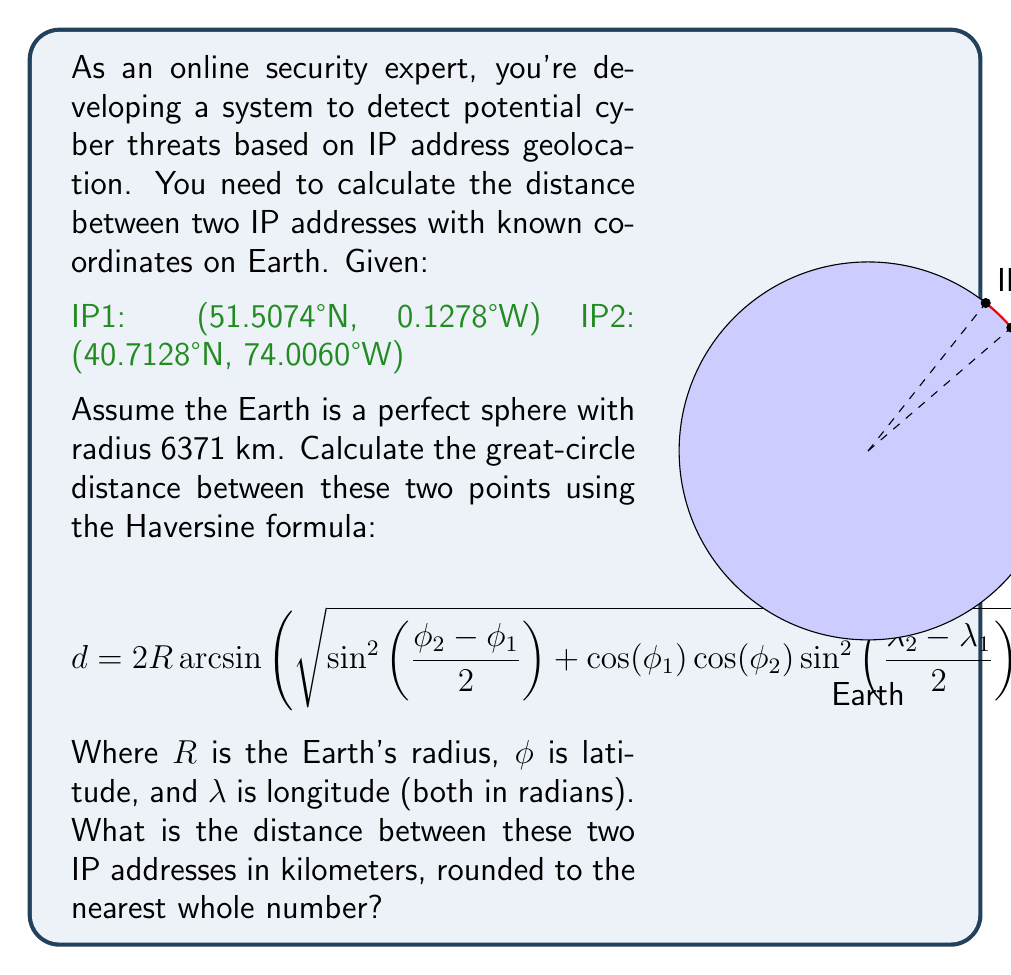Show me your answer to this math problem. To solve this problem, we'll follow these steps:

1) Convert latitudes and longitudes from degrees to radians:
   $\phi_1 = 51.5074° \times \frac{\pi}{180} = 0.8990$ rad
   $\lambda_1 = -0.1278° \times \frac{\pi}{180} = -0.0022$ rad
   $\phi_2 = 40.7128° \times \frac{\pi}{180} = 0.7104$ rad
   $\lambda_2 = -74.0060° \times \frac{\pi}{180} = -1.2915$ rad

2) Calculate the differences:
   $\Delta\phi = \phi_2 - \phi_1 = 0.7104 - 0.8990 = -0.1886$ rad
   $\Delta\lambda = \lambda_2 - \lambda_1 = -1.2915 - (-0.0022) = -1.2893$ rad

3) Apply the Haversine formula:
   $$d = 2R \arcsin\left(\sqrt{\sin^2\left(\frac{\Delta\phi}{2}\right) + \cos(\phi_1)\cos(\phi_2)\sin^2\left(\frac{\Delta\lambda}{2}\right)}\right)$$

   $= 2 \times 6371 \times \arcsin\left(\sqrt{\sin^2\left(\frac{-0.1886}{2}\right) + \cos(0.8990)\cos(0.7104)\sin^2\left(\frac{-1.2893}{2}\right)}\right)$

4) Calculate the result:
   $= 2 \times 6371 \times \arcsin(\sqrt{0.0022 + 0.3984})$
   $= 2 \times 6371 \times \arcsin(\sqrt{0.4006})$
   $= 2 \times 6371 \times \arcsin(0.6329)$
   $= 2 \times 6371 \times 0.6812$
   $= 8681.7$ km

5) Round to the nearest whole number:
   $8682$ km
Answer: 8682 km 